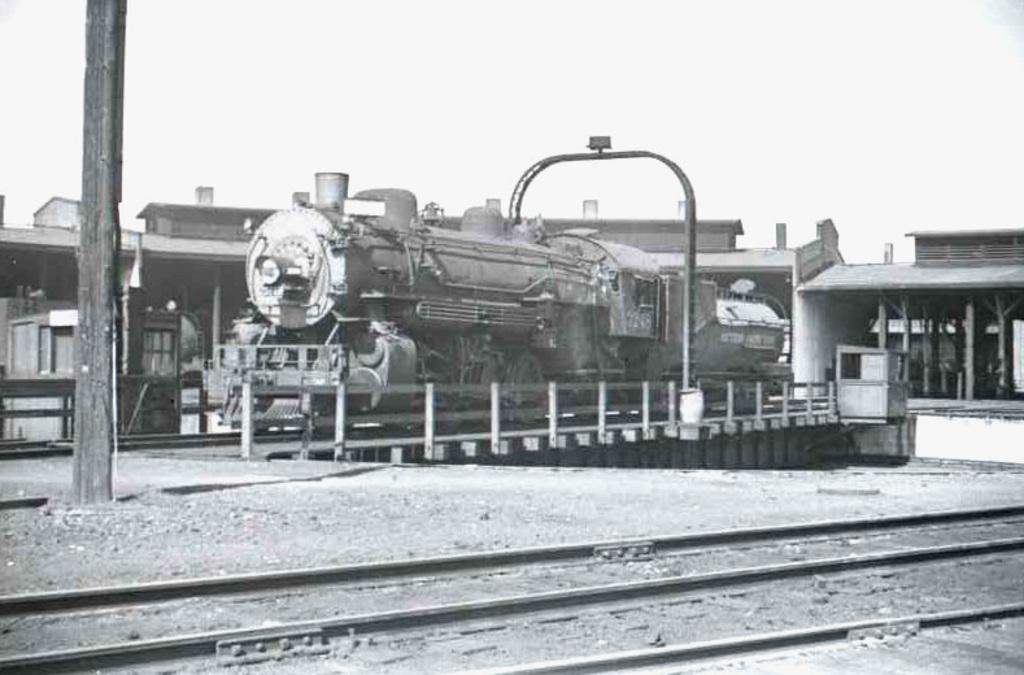What is the main subject of the image? There is a train in the middle of the image. What can be seen beneath the train? There are tracks visible in the image. What type of structures are present in the image? There are buildings in the image. What else can be seen in the image besides the train and buildings? There is a pole in the image. How is the image presented in terms of color? The image is in black and white. Where is the grape located in the image? There is no grape present in the image. What type of land can be seen in the image? The image does not show any specific type of land; it primarily features a train, tracks, buildings, and a pole. 